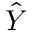<formula> <loc_0><loc_0><loc_500><loc_500>\hat { Y }</formula> 